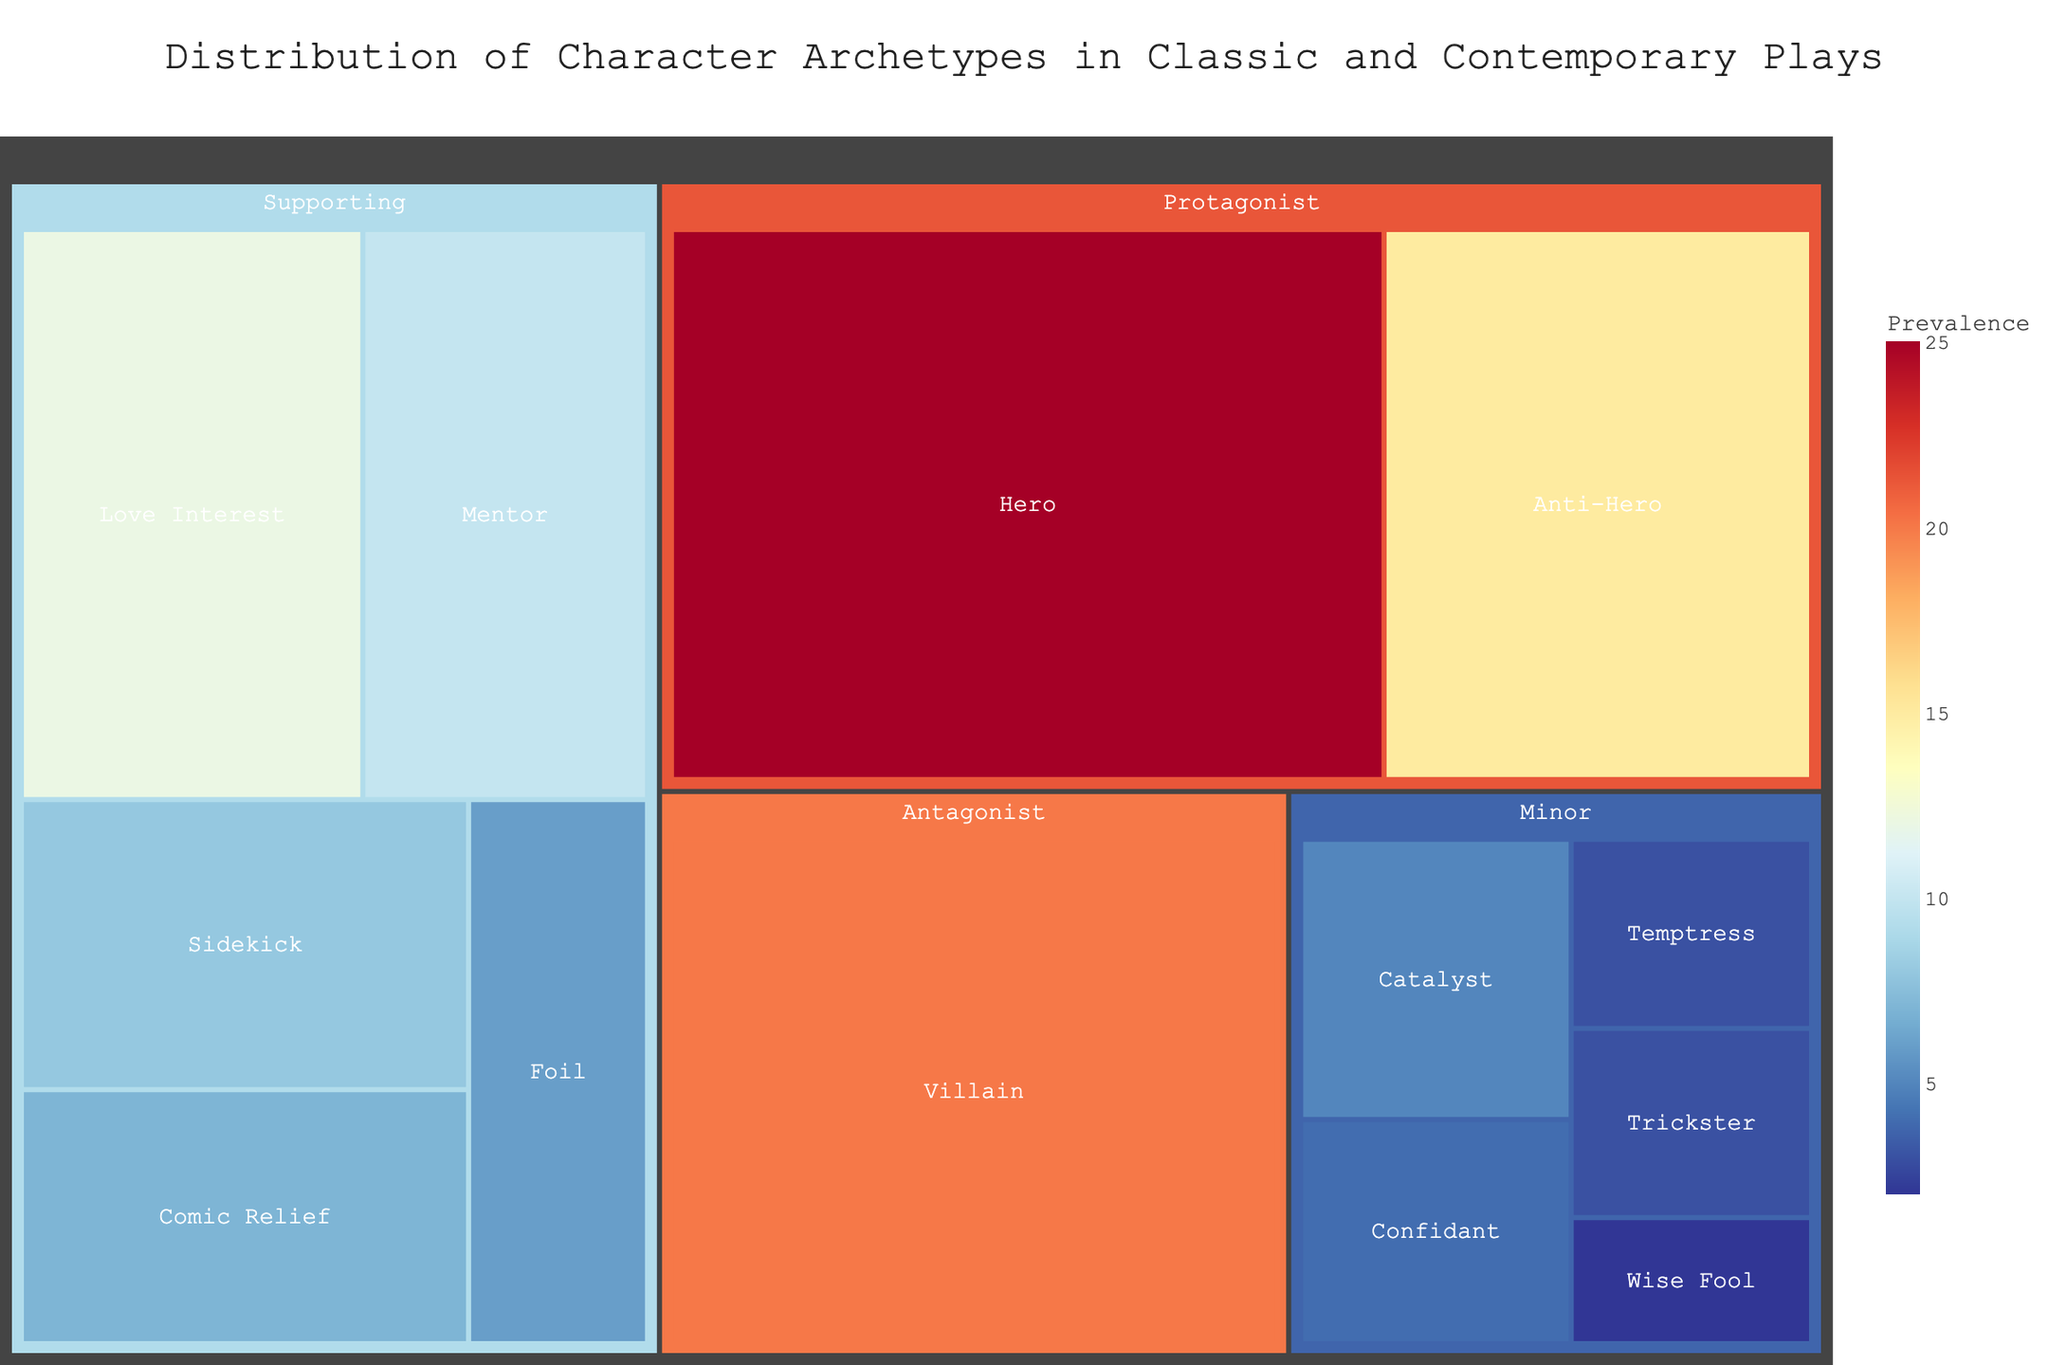Which character archetype has the highest prevalence? The treemap shows a hierarchy with different character archetypes and their prevalence. The largest section represents the archetype with the highest prevalence.
Answer: Hero What is the total prevalence of minor characters? To find this, sum up the prevalence values of all the minor character archetypes shown in the treemap. These are Confidant (4), Trickster (3), Catalyst (5), Temptress (3), and Wise Fool (2). So, 4 + 3 + 5 + 3 + 2 = 17.
Answer: 17 Which supporting character archetype is least prevalent? The supporting character archetypes are Mentor, Sidekick, Love Interest, Comic Relief, and Foil. By comparing their prevalence, we see that Foil has the smallest section, indicating it is the least prevalent.
Answer: Foil Compare the prevalence of Protagonist archetypes Hero and Anti-Hero. Which is more dominant, and by how much? The treemap shows that Hero has a prevalence of 25, while Anti-Hero has a prevalence of 15. The difference can be calculated by subtracting 15 from 25.
Answer: Hero is more dominant by 10 What is the prevalence of the Villain archetype? By examining the section labeled "Villain" within the antagonist category, the prevalence value is shown.
Answer: 20 Is the Comic Relief archetype more or less prevalent than the Love Interest archetype? The treemap indicates that Comic Relief has a prevalence of 7, while Love Interest has a prevalence of 12. By comparing the two values, it is clear that Comic Relief is less prevalent.
Answer: Less prevalent How much more prevalent is the Protagonist archetype than the Antagonist archetype? To determine this, sum the prevalence of all Protagonist archetypes (Hero (25) + Anti-Hero (15)) and compare it with the Antagonist archetype (Villain (20)). The total for Protagonist is 40. The difference is calculated by subtracting 20 from 40.
Answer: 20 What fraction of the total character archetypes does the Sidekick archetype represent? Calculate the total prevalence of all archetypes and then determine the fraction represented by the Sidekick. The total prevalence is obtained by summing all values (25+15+20+10+8+12+7+6+4+3+5+3+2). This is 120. The Sidekick prevalence is 8, so the fraction is 8/120.
Answer: 1/15 